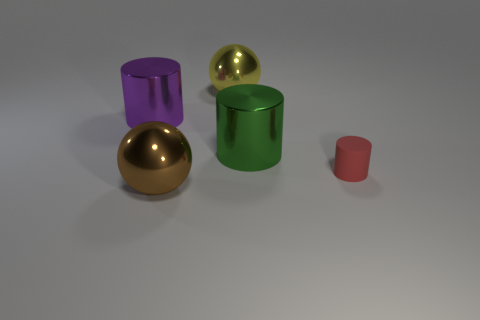Subtract 1 cylinders. How many cylinders are left? 2 Subtract all metallic cylinders. How many cylinders are left? 1 Add 5 big cyan metallic cylinders. How many objects exist? 10 Subtract all spheres. How many objects are left? 3 Add 2 big brown metallic things. How many big brown metallic things exist? 3 Subtract 0 red cubes. How many objects are left? 5 Subtract all brown spheres. Subtract all small blue things. How many objects are left? 4 Add 2 tiny things. How many tiny things are left? 3 